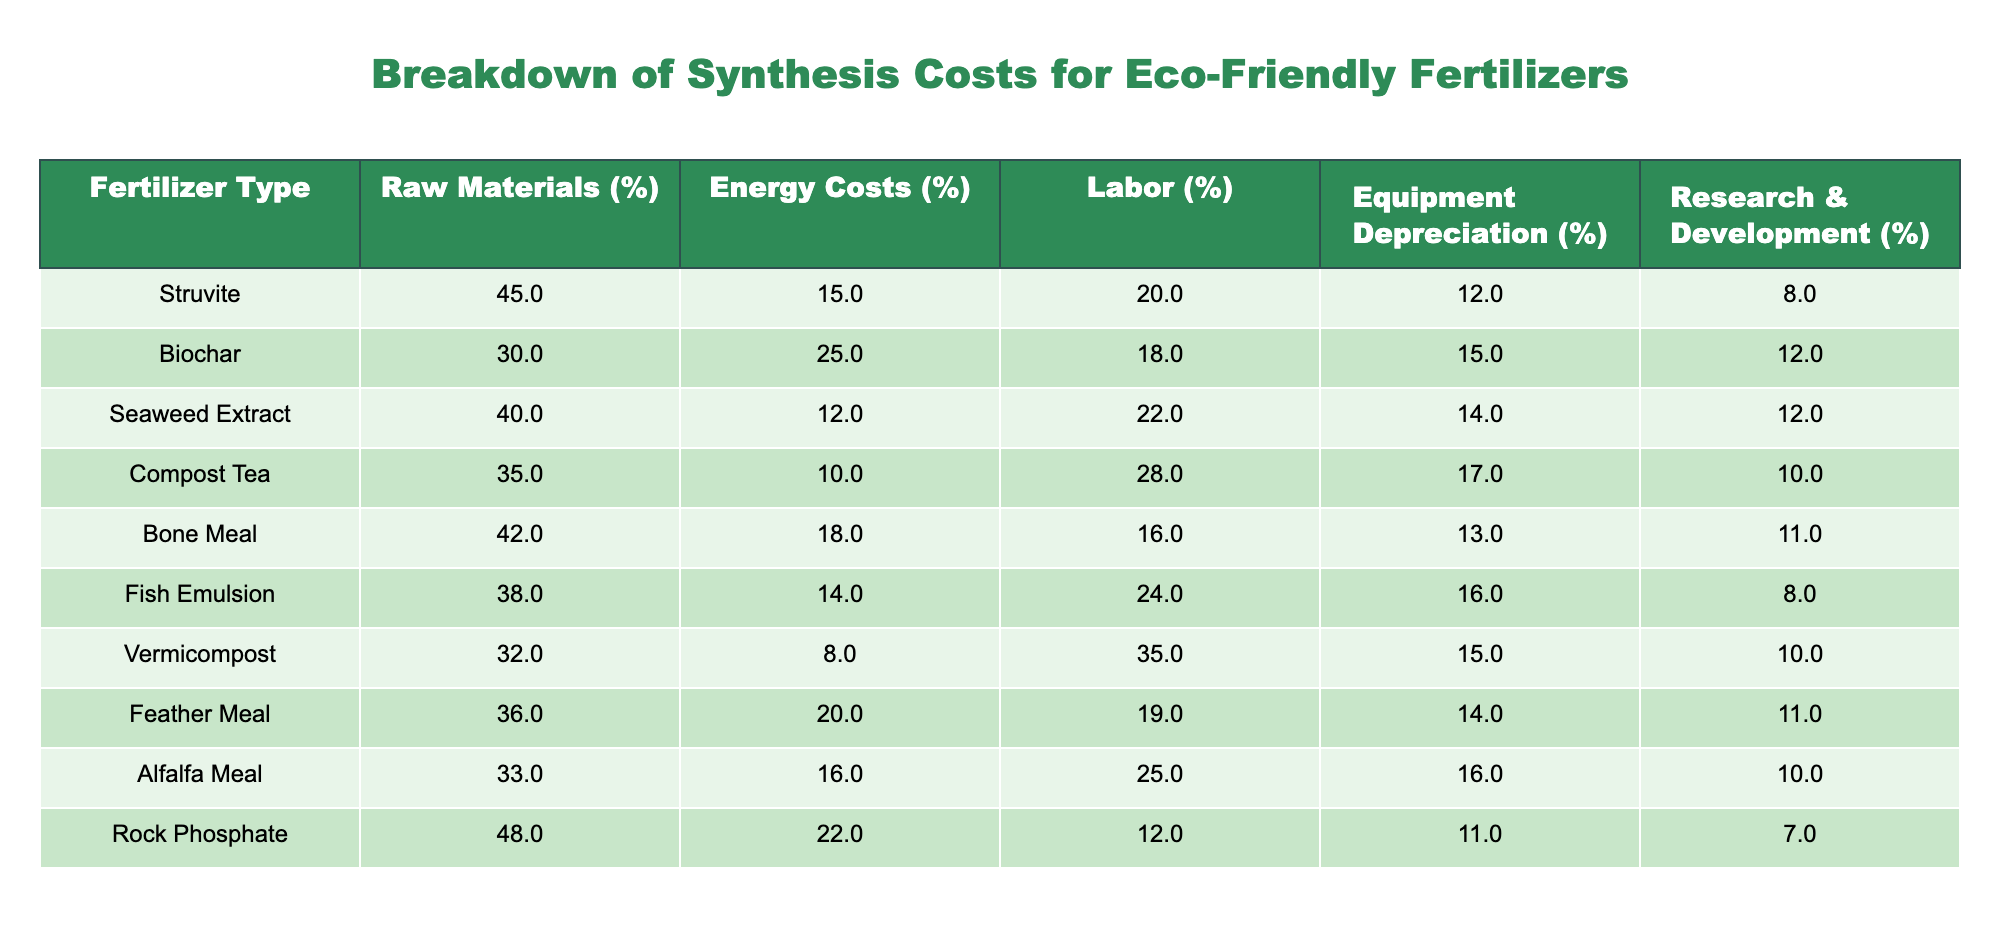What is the raw materials percentage for Biochar? Referring to the table, the raw materials percentage for Biochar is 30%.
Answer: 30% Which eco-friendly fertilizer has the highest energy costs percentage? The table shows that Biochar has the highest energy costs percentage at 25%.
Answer: 25% What is the average labor cost percentage for the fertilizers listed? To find the average labor cost percentage, we sum the labor costs: (20 + 18 + 22 + 28 + 16 + 24 + 35 + 19 + 25 + 12) =  18 + 22 + 28 + 16 + 24 + 35 + 19 + 25 + 12) =  12 + 30 = 300, then divide by the number of fertilizers (10), so 300/10 = 30%.
Answer: 30% Is the equipment depreciation percentage for Seaweed Extract higher than that for Rock Phosphate? Seaweed Extract has an equipment depreciation percentage of 14%, while Rock Phosphate has 11%. Since 14% is greater than 11%, this statement is true.
Answer: Yes What is the difference in raw materials percentage between Struvite and Bone Meal? Struvite has a raw materials percentage of 45%, while Bone Meal has 42%. The difference is 45% - 42% = 3%.
Answer: 3% Which fertilizers have a research and development percentage greater than 10%? The fertilizers with more than 10% in research and development are Biochar (12%), Seaweed Extract (12%), Compost Tea (10%), Bone Meal (11%), and Alfalfa Meal (10%). Thus, the qualifying fertilizers are three: Biochar, Seaweed Extract, and Bone Meal.
Answer: Biochar, Seaweed Extract, Bone Meal What is the total percentage of costs for Labor and Energy for Fish Emulsion? Fish Emulsion has labor costs at 24% and energy costs at 14%. Adding these together gives us 24% + 14% = 38%.
Answer: 38% Which fertilizer has the lowest raw material cost? By comparing the raw materials percentage across all fertilizers, Vermicompost has the lowest raw material cost at 32%.
Answer: 32% What percentage of costs for Compost Tea is attributed to Labor? From the table, Compost Tea attributes 28% of its costs to Labor.
Answer: 28% 